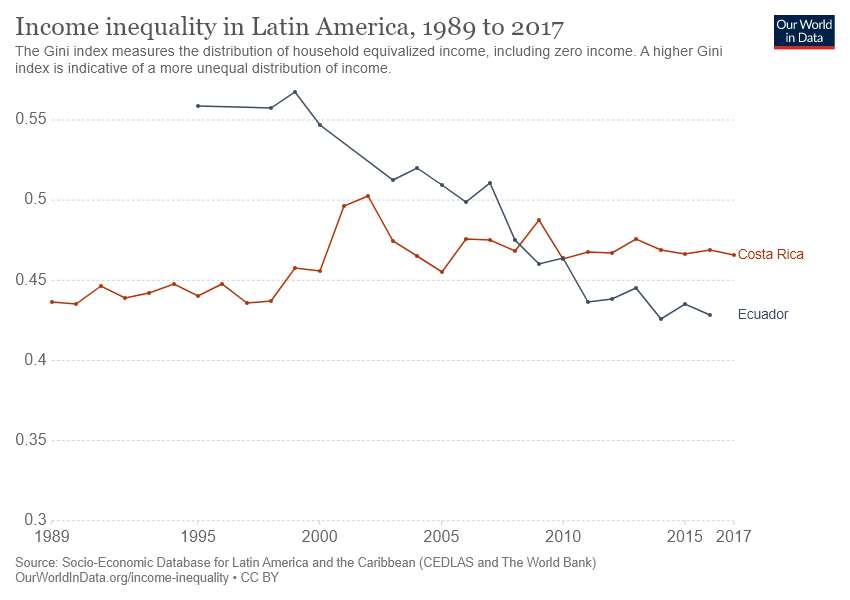Specify some key components in this picture. The value of Costa Rica experienced the sharpest increase in the year 2000. Ecuador experiences more decreases than increases. 